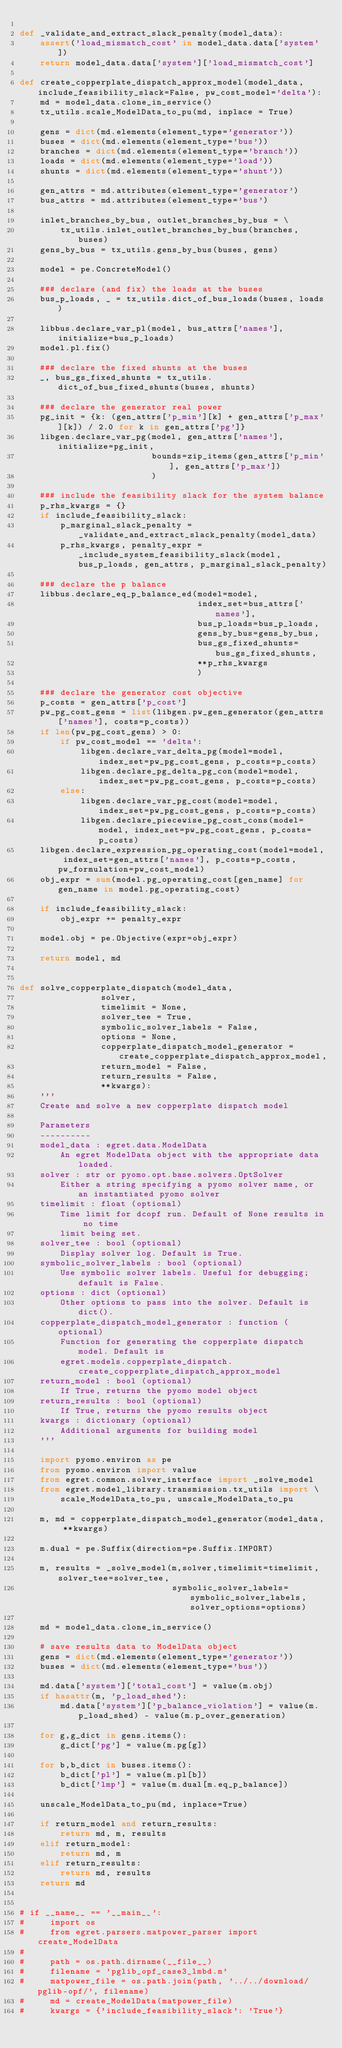<code> <loc_0><loc_0><loc_500><loc_500><_Python_>
def _validate_and_extract_slack_penalty(model_data):
    assert('load_mismatch_cost' in model_data.data['system'])
    return model_data.data['system']['load_mismatch_cost']

def create_copperplate_dispatch_approx_model(model_data, include_feasibility_slack=False, pw_cost_model='delta'):
    md = model_data.clone_in_service()
    tx_utils.scale_ModelData_to_pu(md, inplace = True)

    gens = dict(md.elements(element_type='generator'))
    buses = dict(md.elements(element_type='bus'))
    branches = dict(md.elements(element_type='branch'))
    loads = dict(md.elements(element_type='load'))
    shunts = dict(md.elements(element_type='shunt'))

    gen_attrs = md.attributes(element_type='generator')
    bus_attrs = md.attributes(element_type='bus')

    inlet_branches_by_bus, outlet_branches_by_bus = \
        tx_utils.inlet_outlet_branches_by_bus(branches, buses)
    gens_by_bus = tx_utils.gens_by_bus(buses, gens)

    model = pe.ConcreteModel()

    ### declare (and fix) the loads at the buses
    bus_p_loads, _ = tx_utils.dict_of_bus_loads(buses, loads)

    libbus.declare_var_pl(model, bus_attrs['names'], initialize=bus_p_loads)
    model.pl.fix()

    ### declare the fixed shunts at the buses
    _, bus_gs_fixed_shunts = tx_utils.dict_of_bus_fixed_shunts(buses, shunts)

    ### declare the generator real power
    pg_init = {k: (gen_attrs['p_min'][k] + gen_attrs['p_max'][k]) / 2.0 for k in gen_attrs['pg']}
    libgen.declare_var_pg(model, gen_attrs['names'], initialize=pg_init,
                          bounds=zip_items(gen_attrs['p_min'], gen_attrs['p_max'])
                          )

    ### include the feasibility slack for the system balance
    p_rhs_kwargs = {}
    if include_feasibility_slack:
        p_marginal_slack_penalty = _validate_and_extract_slack_penalty(model_data)                
        p_rhs_kwargs, penalty_expr = _include_system_feasibility_slack(model, bus_p_loads, gen_attrs, p_marginal_slack_penalty)

    ### declare the p balance
    libbus.declare_eq_p_balance_ed(model=model,
                                   index_set=bus_attrs['names'],
                                   bus_p_loads=bus_p_loads,
                                   gens_by_bus=gens_by_bus,
                                   bus_gs_fixed_shunts=bus_gs_fixed_shunts,
                                   **p_rhs_kwargs
                                   )

    ### declare the generator cost objective
    p_costs = gen_attrs['p_cost']
    pw_pg_cost_gens = list(libgen.pw_gen_generator(gen_attrs['names'], costs=p_costs))
    if len(pw_pg_cost_gens) > 0:
        if pw_cost_model == 'delta':
            libgen.declare_var_delta_pg(model=model, index_set=pw_pg_cost_gens, p_costs=p_costs)
            libgen.declare_pg_delta_pg_con(model=model, index_set=pw_pg_cost_gens, p_costs=p_costs)
        else:
            libgen.declare_var_pg_cost(model=model, index_set=pw_pg_cost_gens, p_costs=p_costs)
            libgen.declare_piecewise_pg_cost_cons(model=model, index_set=pw_pg_cost_gens, p_costs=p_costs)
    libgen.declare_expression_pg_operating_cost(model=model, index_set=gen_attrs['names'], p_costs=p_costs, pw_formulation=pw_cost_model)
    obj_expr = sum(model.pg_operating_cost[gen_name] for gen_name in model.pg_operating_cost)

    if include_feasibility_slack:
        obj_expr += penalty_expr

    model.obj = pe.Objective(expr=obj_expr)

    return model, md


def solve_copperplate_dispatch(model_data,
                solver,
                timelimit = None,
                solver_tee = True,
                symbolic_solver_labels = False,
                options = None,
                copperplate_dispatch_model_generator = create_copperplate_dispatch_approx_model,
                return_model = False,
                return_results = False,
                **kwargs):
    '''
    Create and solve a new copperplate dispatch model

    Parameters
    ----------
    model_data : egret.data.ModelData
        An egret ModelData object with the appropriate data loaded.
    solver : str or pyomo.opt.base.solvers.OptSolver
        Either a string specifying a pyomo solver name, or an instantiated pyomo solver
    timelimit : float (optional)
        Time limit for dcopf run. Default of None results in no time
        limit being set.
    solver_tee : bool (optional)
        Display solver log. Default is True.
    symbolic_solver_labels : bool (optional)
        Use symbolic solver labels. Useful for debugging; default is False.
    options : dict (optional)
        Other options to pass into the solver. Default is dict().
    copperplate_dispatch_model_generator : function (optional)
        Function for generating the copperplate dispatch model. Default is
        egret.models.copperplate_dispatch.create_copperplate_dispatch_approx_model
    return_model : bool (optional)
        If True, returns the pyomo model object
    return_results : bool (optional)
        If True, returns the pyomo results object
    kwargs : dictionary (optional)
        Additional arguments for building model
    '''

    import pyomo.environ as pe
    from pyomo.environ import value
    from egret.common.solver_interface import _solve_model
    from egret.model_library.transmission.tx_utils import \
        scale_ModelData_to_pu, unscale_ModelData_to_pu

    m, md = copperplate_dispatch_model_generator(model_data, **kwargs)

    m.dual = pe.Suffix(direction=pe.Suffix.IMPORT)

    m, results = _solve_model(m,solver,timelimit=timelimit,solver_tee=solver_tee,
                              symbolic_solver_labels=symbolic_solver_labels,solver_options=options)

    md = model_data.clone_in_service()

    # save results data to ModelData object
    gens = dict(md.elements(element_type='generator'))
    buses = dict(md.elements(element_type='bus'))

    md.data['system']['total_cost'] = value(m.obj)
    if hasattr(m, 'p_load_shed'):
        md.data['system']['p_balance_violation'] = value(m.p_load_shed) - value(m.p_over_generation)

    for g,g_dict in gens.items():
        g_dict['pg'] = value(m.pg[g])

    for b,b_dict in buses.items():
        b_dict['pl'] = value(m.pl[b])
        b_dict['lmp'] = value(m.dual[m.eq_p_balance])

    unscale_ModelData_to_pu(md, inplace=True)

    if return_model and return_results:
        return md, m, results
    elif return_model:
        return md, m
    elif return_results:
        return md, results
    return md


# if __name__ == '__main__':
#     import os
#     from egret.parsers.matpower_parser import create_ModelData
#
#     path = os.path.dirname(__file__)
#     filename = 'pglib_opf_case3_lmbd.m'
#     matpower_file = os.path.join(path, '../../download/pglib-opf/', filename)
#     md = create_ModelData(matpower_file)
#     kwargs = {'include_feasibility_slack': 'True'}</code> 